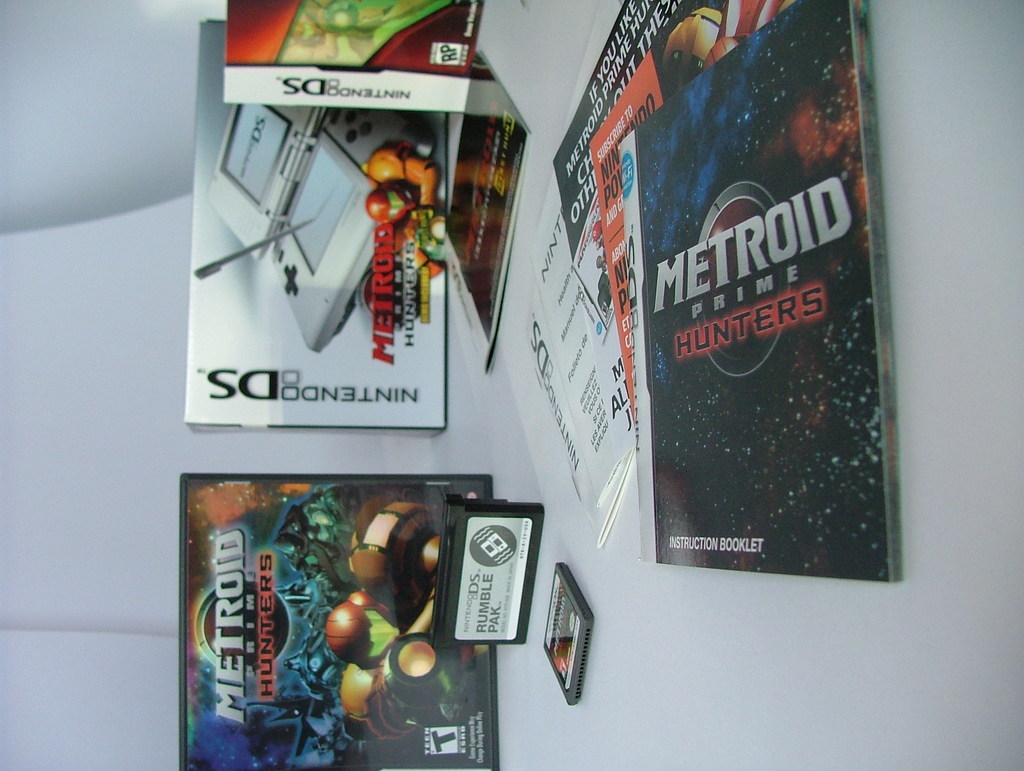<image>
Provide a brief description of the given image. Video Game Posters and games that are sitting on a desk, text saying Metroid Prime Hunters. 